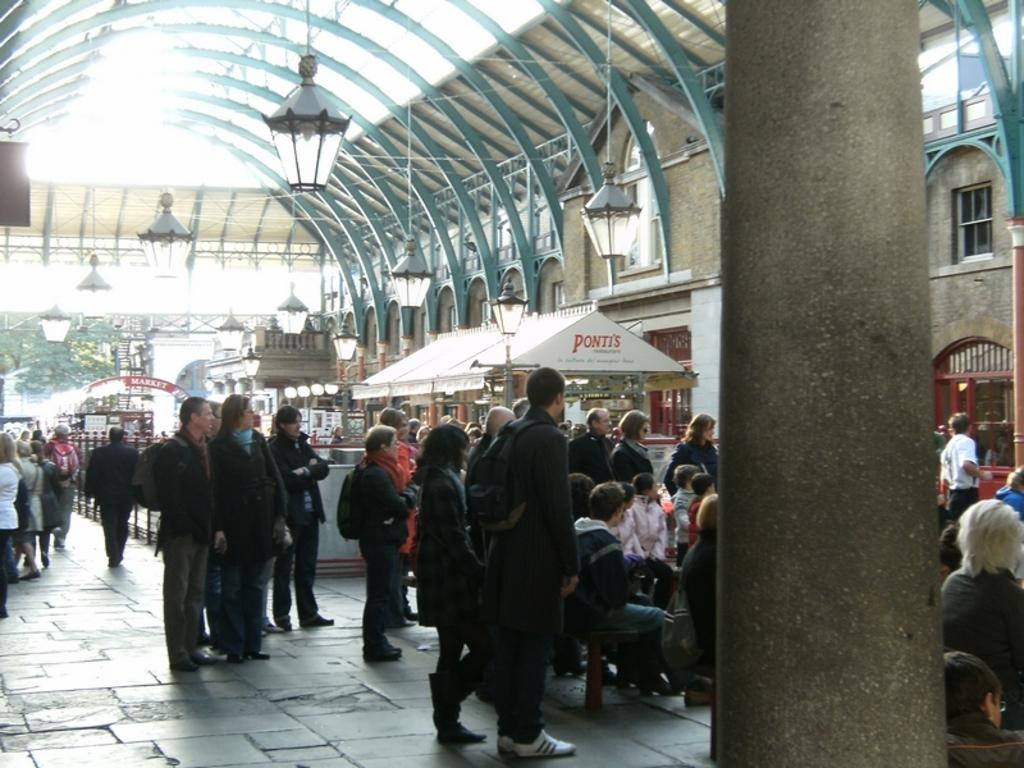<image>
Summarize the visual content of the image. People are gathered around tables with umbrellas advertising Ponti's. 